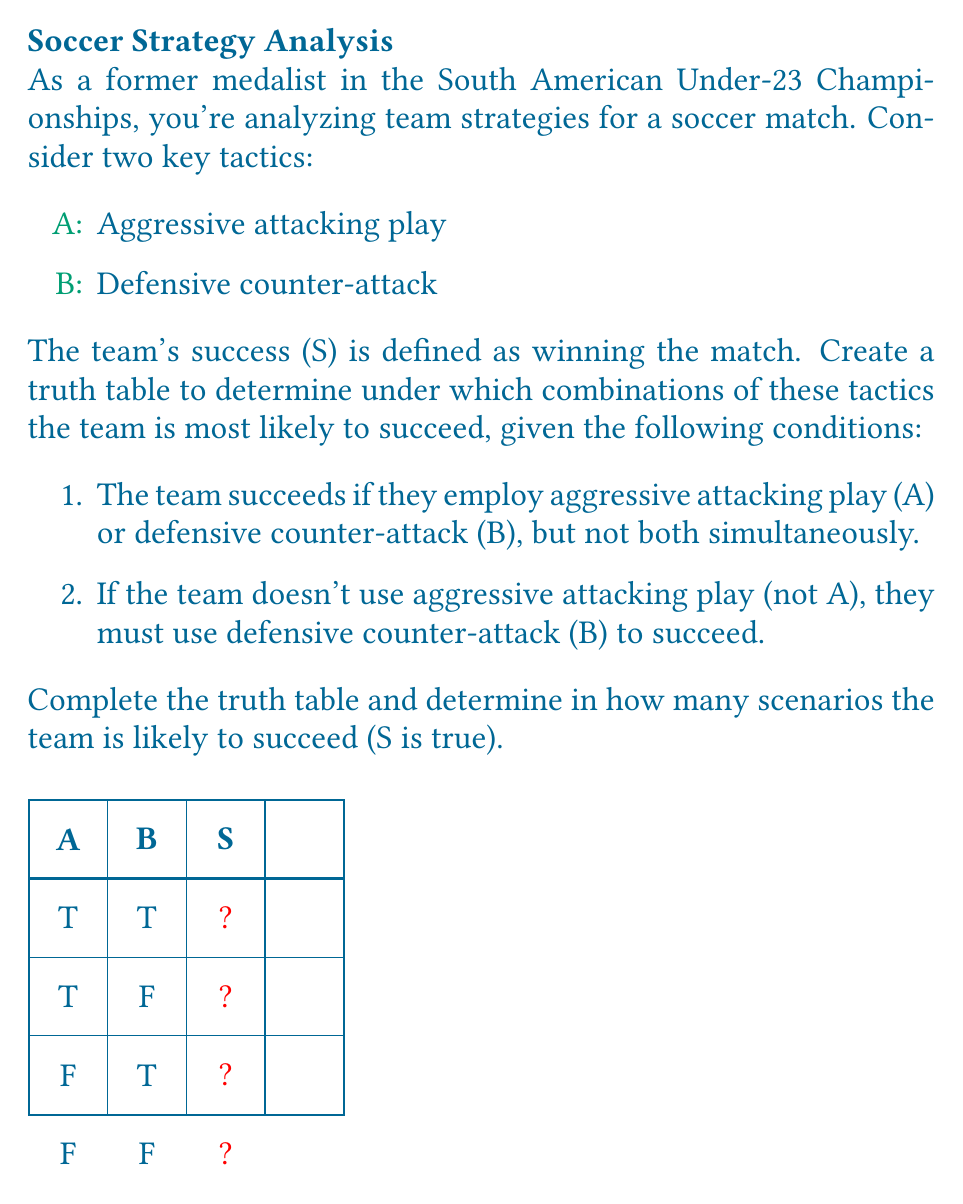Help me with this question. Let's approach this step-by-step:

1) First, we need to understand the logical conditions given:
   - Condition 1: $S = (A \oplus B)$ where $\oplus$ is the exclusive OR (XOR) operation
   - Condition 2: $S = \neg A \rightarrow B$ which is equivalent to $S = A \lor B$

2) We can combine these conditions using the AND operation:
   $S = (A \oplus B) \land (A \lor B)$

3) Now, let's fill in the truth table:

   For A = T, B = T:
   $(T \oplus T) \land (T \lor T) = F \land T = F$

   For A = T, B = F:
   $(T \oplus F) \land (T \lor F) = T \land T = T$

   For A = F, B = T:
   $(F \oplus T) \land (F \lor T) = T \land T = T$

   For A = F, B = F:
   $(F \oplus F) \land (F \lor F) = F \land F = F$

4) The completed truth table looks like this:

   A | B | S
   T | T | F
   T | F | T
   F | T | T
   F | F | F

5) Counting the number of true outcomes for S, we see that there are 2 scenarios where the team is likely to succeed.

This analysis shows that the team is most likely to succeed when they employ either aggressive attacking play or defensive counter-attack, but not both simultaneously, which aligns with the given conditions.
Answer: 2 scenarios 